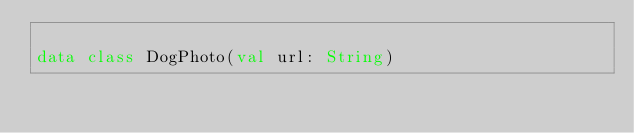Convert code to text. <code><loc_0><loc_0><loc_500><loc_500><_Kotlin_>
data class DogPhoto(val url: String)</code> 